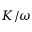Convert formula to latex. <formula><loc_0><loc_0><loc_500><loc_500>K / \omega</formula> 